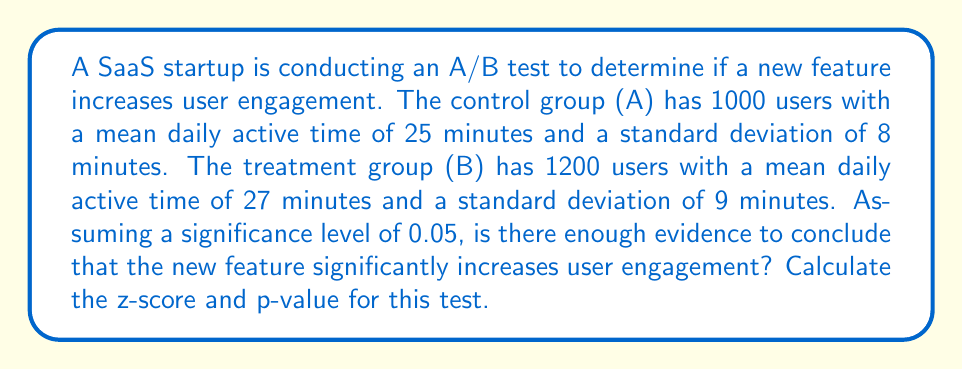Show me your answer to this math problem. To determine if there's a significant difference between the two groups, we'll perform a two-sample z-test:

1. State the null and alternative hypotheses:
   $H_0: \mu_B - \mu_A = 0$
   $H_a: \mu_B - \mu_A > 0$

2. Calculate the standard error of the difference between means:
   $SE = \sqrt{\frac{s_A^2}{n_A} + \frac{s_B^2}{n_B}}$
   $SE = \sqrt{\frac{8^2}{1000} + \frac{9^2}{1200}} = \sqrt{0.064 + 0.0675} = \sqrt{0.1315} = 0.3627$

3. Calculate the z-score:
   $z = \frac{(\bar{x}_B - \bar{x}_A) - (\mu_B - \mu_A)}{SE}$
   $z = \frac{(27 - 25) - 0}{0.3627} = \frac{2}{0.3627} = 5.5142$

4. Find the p-value:
   For a one-tailed test, p-value = $P(Z > 5.5142)$
   Using a standard normal distribution table or calculator:
   p-value $\approx 1.75 \times 10^{-8}$

5. Compare the p-value to the significance level:
   $1.75 \times 10^{-8} < 0.05$

Since the p-value is less than the significance level, we reject the null hypothesis.
Answer: $z = 5.5142$, $p = 1.75 \times 10^{-8}$. Significant increase in engagement. 